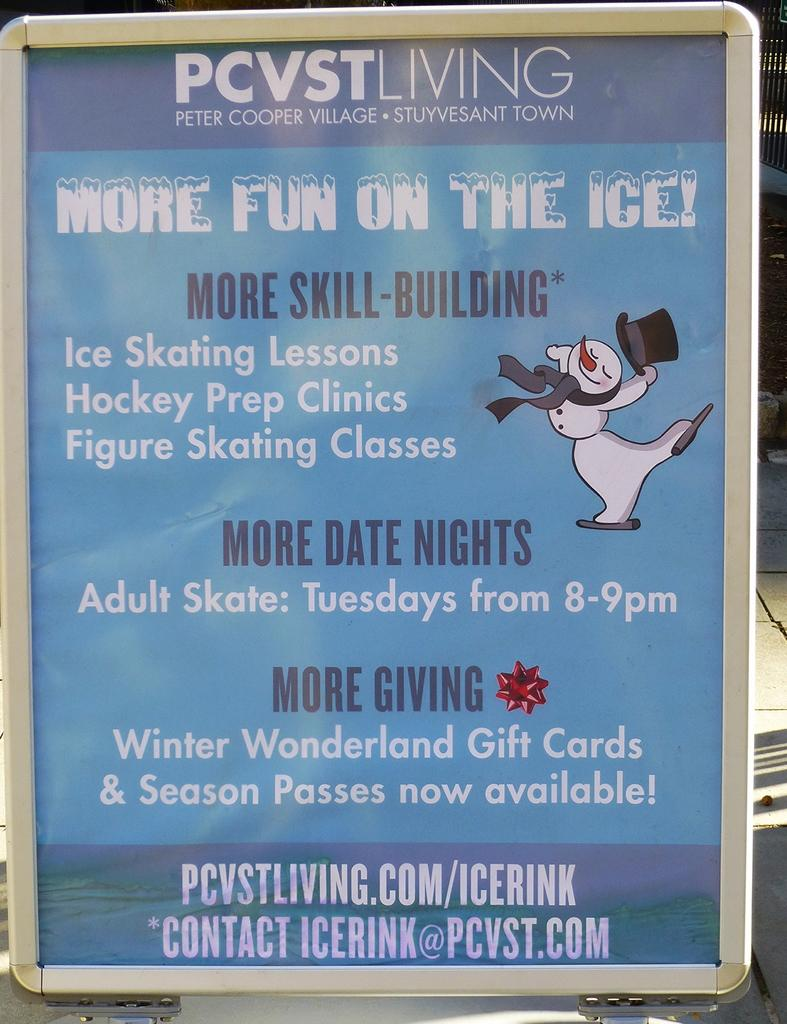<image>
Relay a brief, clear account of the picture shown. Peter Cooper Village has a sign offering ice skating lessons. 